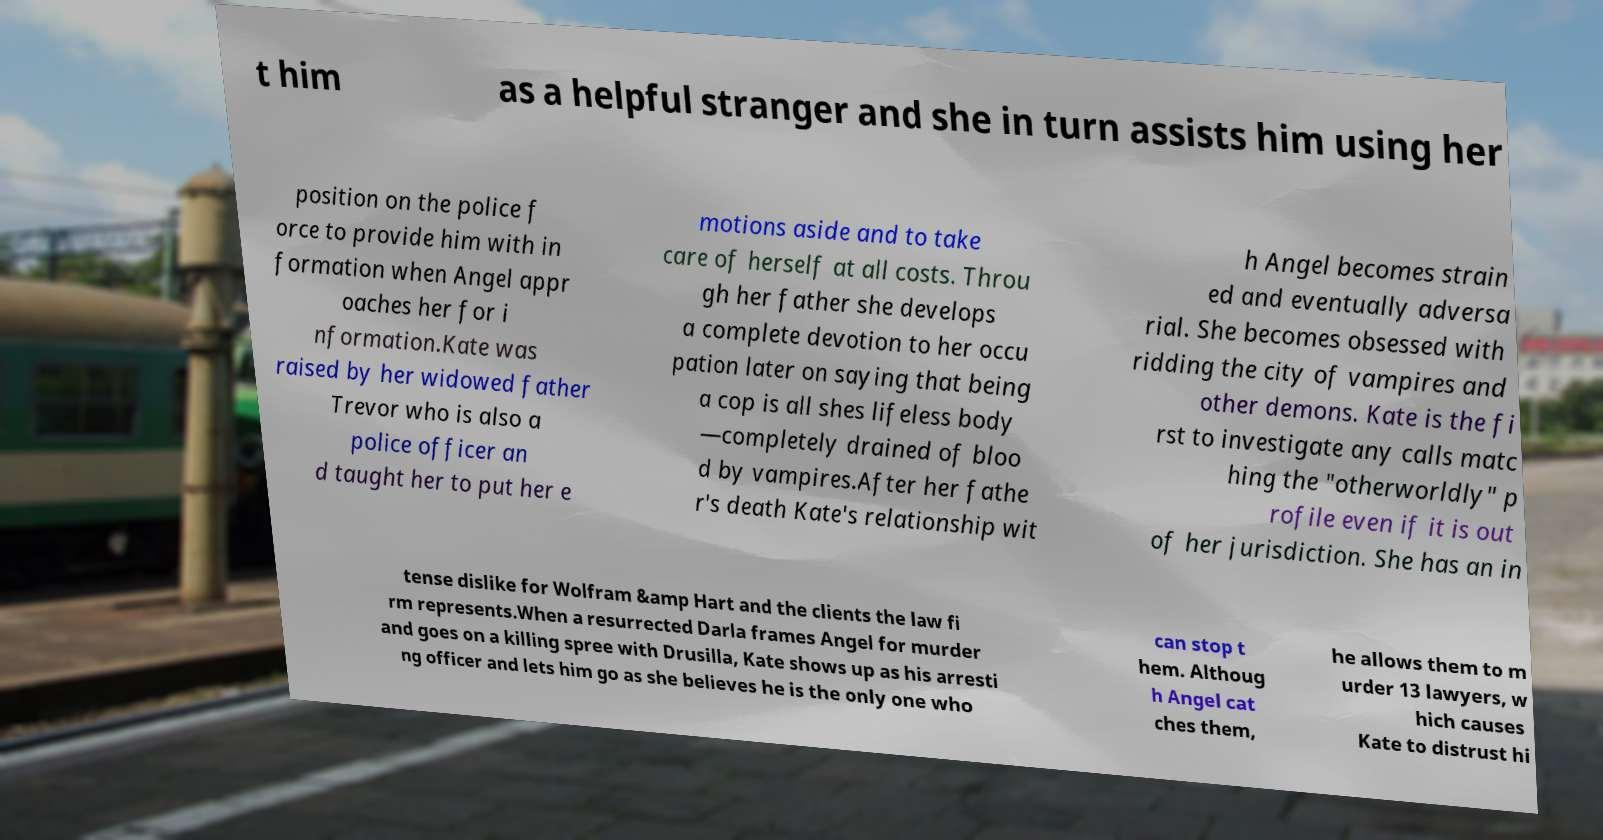I need the written content from this picture converted into text. Can you do that? t him as a helpful stranger and she in turn assists him using her position on the police f orce to provide him with in formation when Angel appr oaches her for i nformation.Kate was raised by her widowed father Trevor who is also a police officer an d taught her to put her e motions aside and to take care of herself at all costs. Throu gh her father she develops a complete devotion to her occu pation later on saying that being a cop is all shes lifeless body —completely drained of bloo d by vampires.After her fathe r's death Kate's relationship wit h Angel becomes strain ed and eventually adversa rial. She becomes obsessed with ridding the city of vampires and other demons. Kate is the fi rst to investigate any calls matc hing the "otherworldly" p rofile even if it is out of her jurisdiction. She has an in tense dislike for Wolfram &amp Hart and the clients the law fi rm represents.When a resurrected Darla frames Angel for murder and goes on a killing spree with Drusilla, Kate shows up as his arresti ng officer and lets him go as she believes he is the only one who can stop t hem. Althoug h Angel cat ches them, he allows them to m urder 13 lawyers, w hich causes Kate to distrust hi 